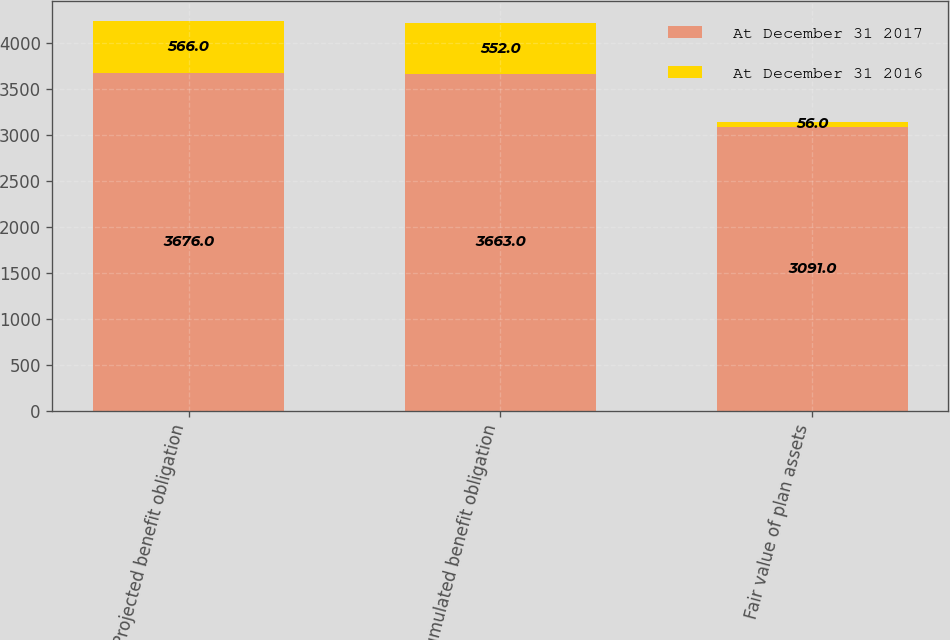Convert chart to OTSL. <chart><loc_0><loc_0><loc_500><loc_500><stacked_bar_chart><ecel><fcel>Projected benefit obligation<fcel>Accumulated benefit obligation<fcel>Fair value of plan assets<nl><fcel>At December 31 2017<fcel>3676<fcel>3663<fcel>3091<nl><fcel>At December 31 2016<fcel>566<fcel>552<fcel>56<nl></chart> 